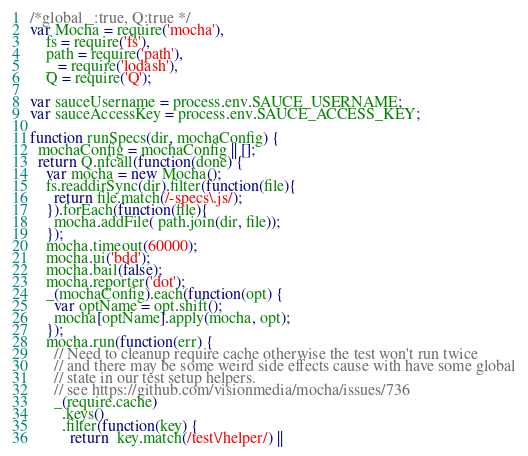<code> <loc_0><loc_0><loc_500><loc_500><_JavaScript_>/*global _:true, Q:true */
var Mocha = require('mocha'),
    fs = require('fs'),
    path = require('path'),
    _ = require('lodash'),
    Q = require('Q');

var sauceUsername = process.env.SAUCE_USERNAME;
var sauceAccessKey = process.env.SAUCE_ACCESS_KEY;

function runSpecs(dir, mochaConfig) {
  mochaConfig = mochaConfig || [];
  return Q.nfcall(function(done) {
    var mocha = new Mocha();
    fs.readdirSync(dir).filter(function(file){
      return file.match(/-specs\.js/);
    }).forEach(function(file){
      mocha.addFile( path.join(dir, file));
    });
    mocha.timeout(60000);
    mocha.ui('bdd');
    mocha.bail(false);
    mocha.reporter('dot');
    _(mochaConfig).each(function(opt) {
      var optName = opt.shift();
      mocha[optName].apply(mocha, opt);
    });
    mocha.run(function(err) {
      // Need to cleanup require cache otherwise the test won't run twice
      // and there may be some weird side effects cause with have some global
      // state in our test setup helpers.
      // see https://github.com/visionmedia/mocha/issues/736
      _(require.cache)
        .keys()
        .filter(function(key) {
          return  key.match(/test\/helper/) ||</code> 